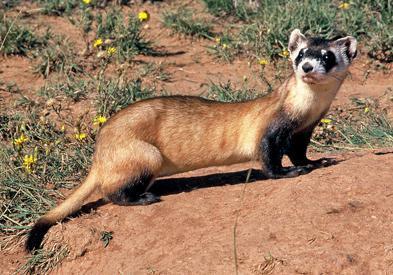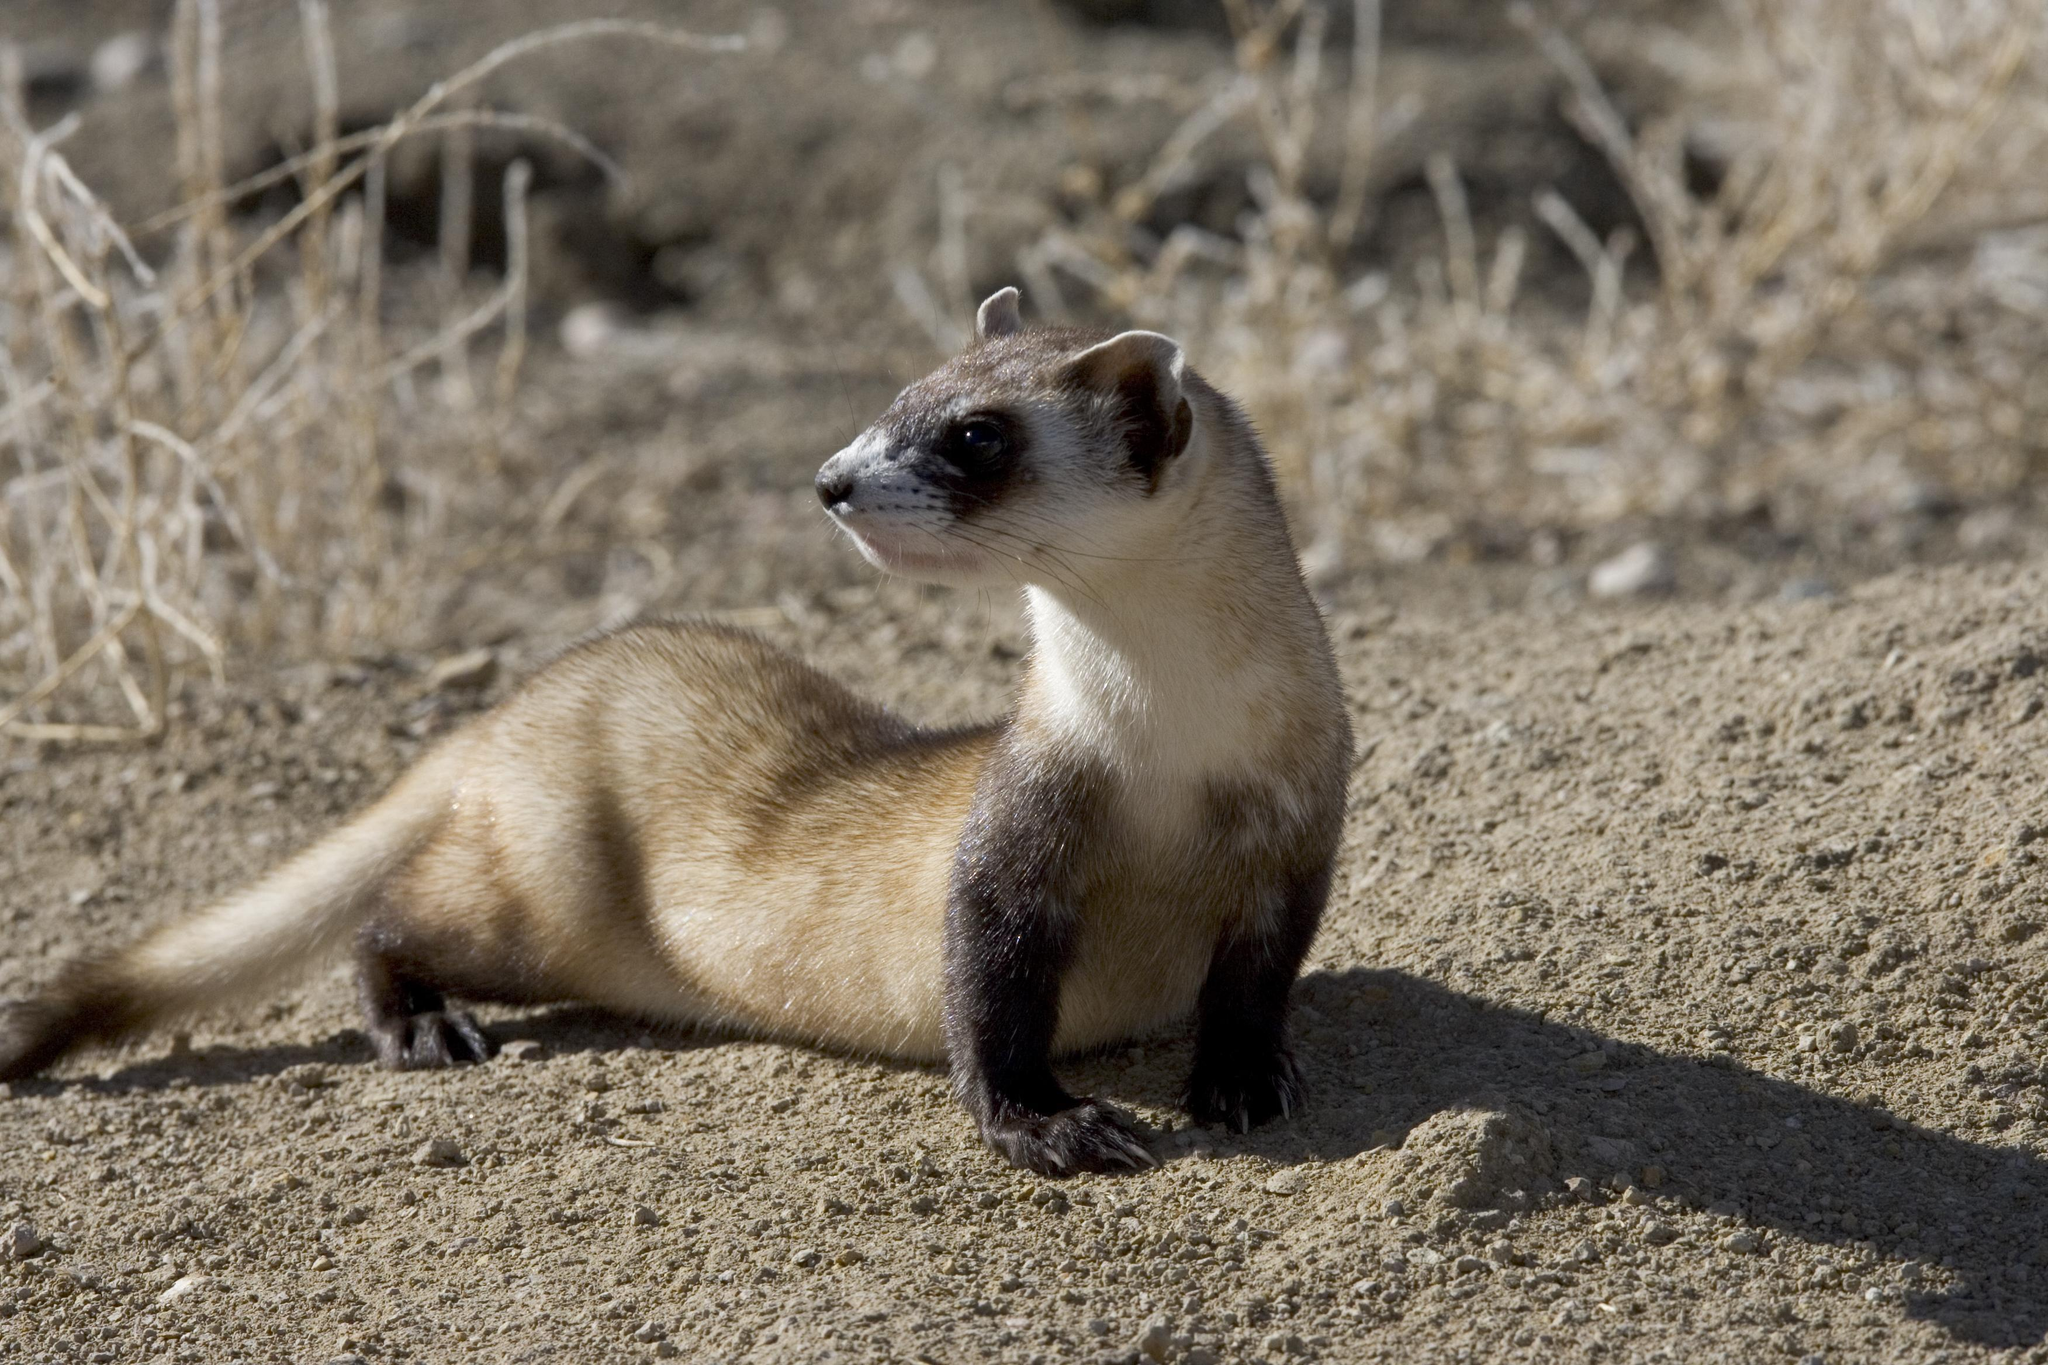The first image is the image on the left, the second image is the image on the right. Given the left and right images, does the statement "In the image on the right, a small portion of the ferret's body is occluded by some of the grass." hold true? Answer yes or no. No. The first image is the image on the left, the second image is the image on the right. Assess this claim about the two images: "At least one ferret is emerging from a hole and looking in the distance.". Correct or not? Answer yes or no. No. 